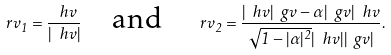<formula> <loc_0><loc_0><loc_500><loc_500>\ r v _ { 1 } = \frac { \ h v } { | \ h v | } \quad \text {and} \quad \ r v _ { 2 } = \frac { | \ h v | \ g v - \alpha | \ g v | \ h v } { \sqrt { 1 - | \alpha | ^ { 2 } } | \ h v | | \ g v | } .</formula> 